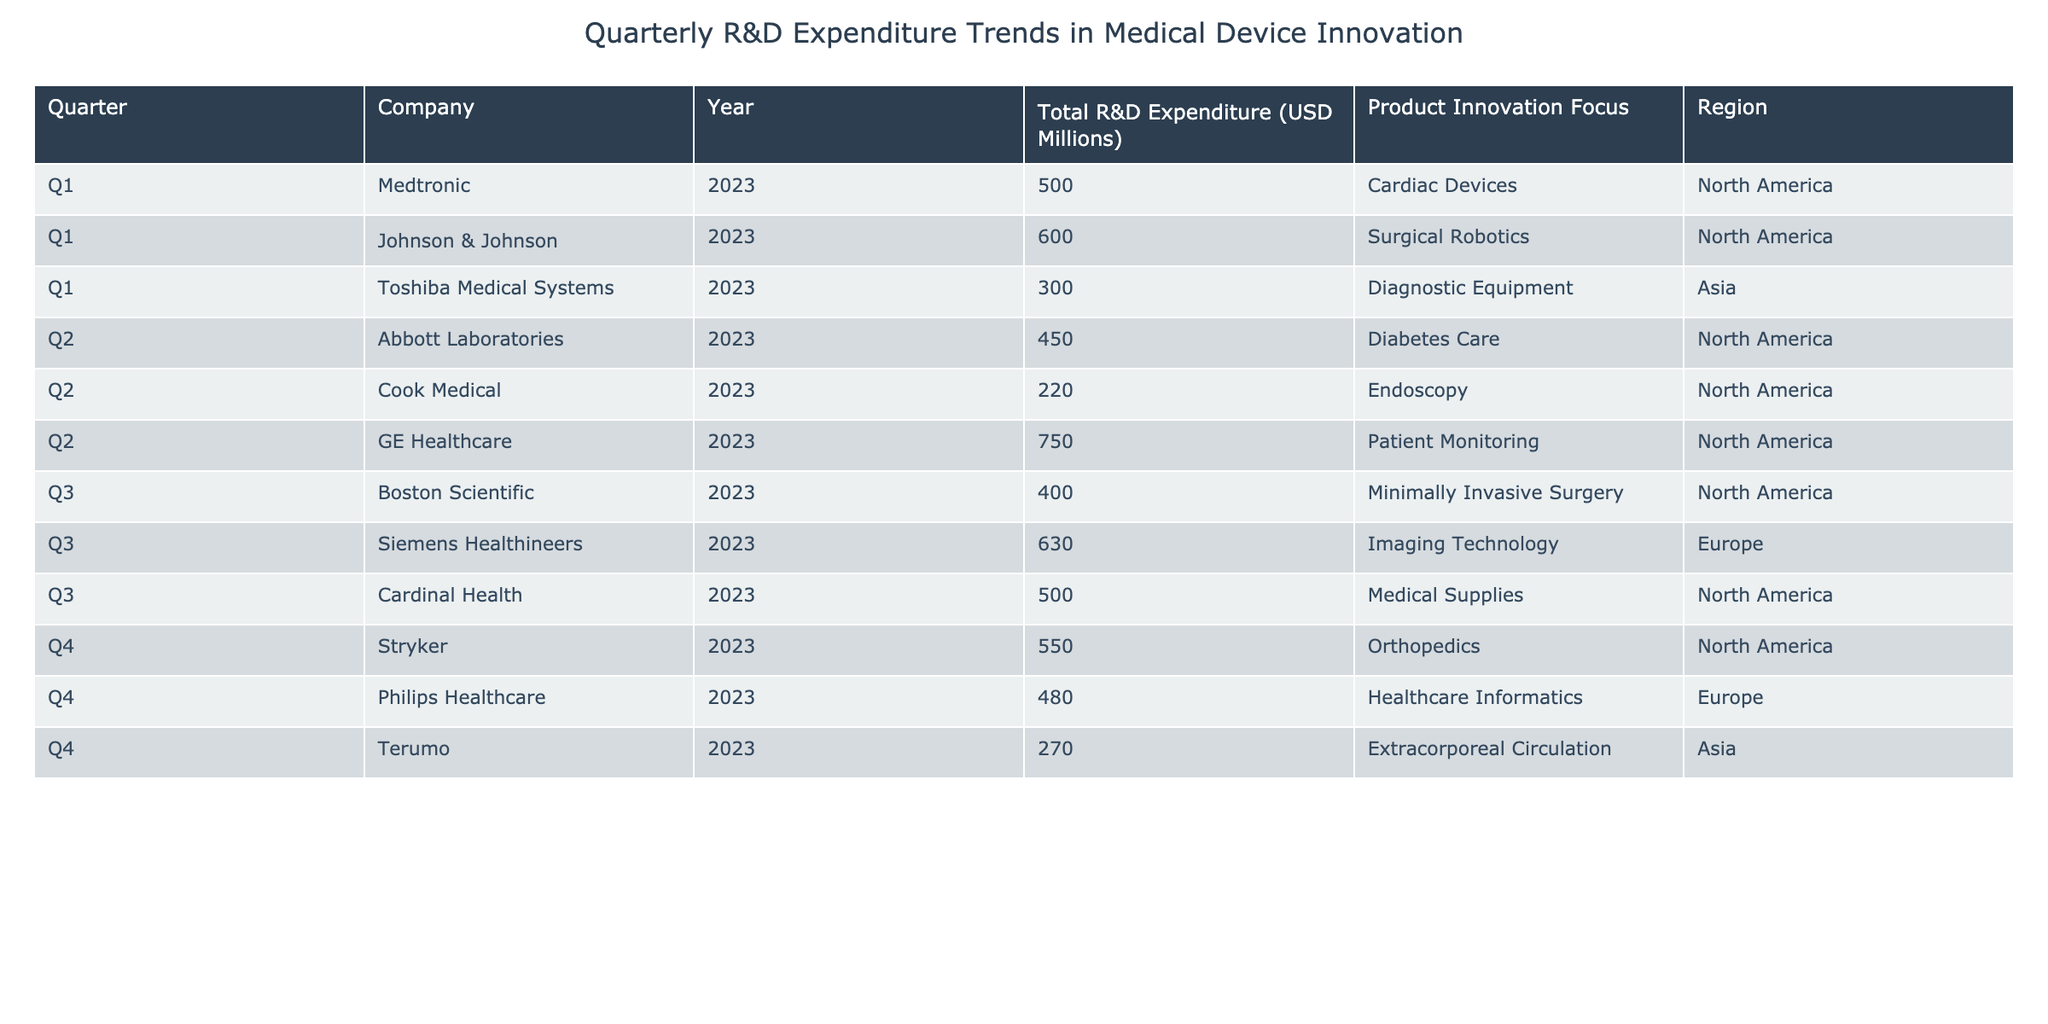What is the total R&D expenditure for Siemens Healthineers in Q3 2023? The table indicates that Siemens Healthineers has a Total R&D Expenditure of 630 million USD for Q3 in the year 2023.
Answer: 630 million USD Which company had the highest R&D expenditure in Q4 2023? In Q4 2023, the table shows that Stryker had the highest expenditure of 550 million USD compared to other companies listed for that quarter.
Answer: Stryker What is the average R&D expenditure across all companies for Q1 2023? The total R&D expenditure for Q1 2023 can be calculated by summing the expenditures of Medtronic (500) and Johnson & Johnson (600), resulting in a total of 1100 million USD for two companies. Dividing this sum by 2 gives an average of 550 million USD.
Answer: 550 million USD Did Cook Medical have a higher or lower expenditure than Terumo in 2023? By comparing the expenditures, Cook Medical is listed with 220 million USD for Q2, whereas Terumo has 270 million USD in Q4. Since 220 million is less than 270 million, Cook Medical had a lower expenditure than Terumo in 2023.
Answer: Lower What is the total expenditure for all companies in the Diabetes Care product focus? Only Abbott Laboratories focuses on Diabetes Care with an expenditure of 450 million USD in Q2 2023. Therefore, the total expenditure specifically for this product focus is 450 million USD.
Answer: 450 million USD How much greater was GE Healthcare's R&D expenditure than Boston Scientific's in Q3 2023? GE Healthcare has an expenditure of 750 million USD, while Boston Scientific's expenditure for Q3 is 400 million USD. The difference can be calculated as 750 - 400 = 350 million USD, indicating GE Healthcare spent 350 million USD more.
Answer: 350 million USD Which region had the highest total R&D expenditure across all four quarters? To determine this, we must add the R&D expenditures by region. In total, North America has 500 + 450 + 400 + 550 + 600 + 220 + 750 + 500 = 3420 million USD; Europe has 630 + 480 = 1110 million USD; and Asia has 300 + 270 = 570 million USD. Comparing these totals reveals that North America had the highest expenditure.
Answer: North America Is Stryker the only company to invest in Orthopedics in 2023? The table indicates that Stryker has a focus on Orthopedics for Q4 2023. There is no other mention of a company focusing on Orthopedics in the data provided, confirming Stryker as the only company in this focus area for 2023.
Answer: Yes 